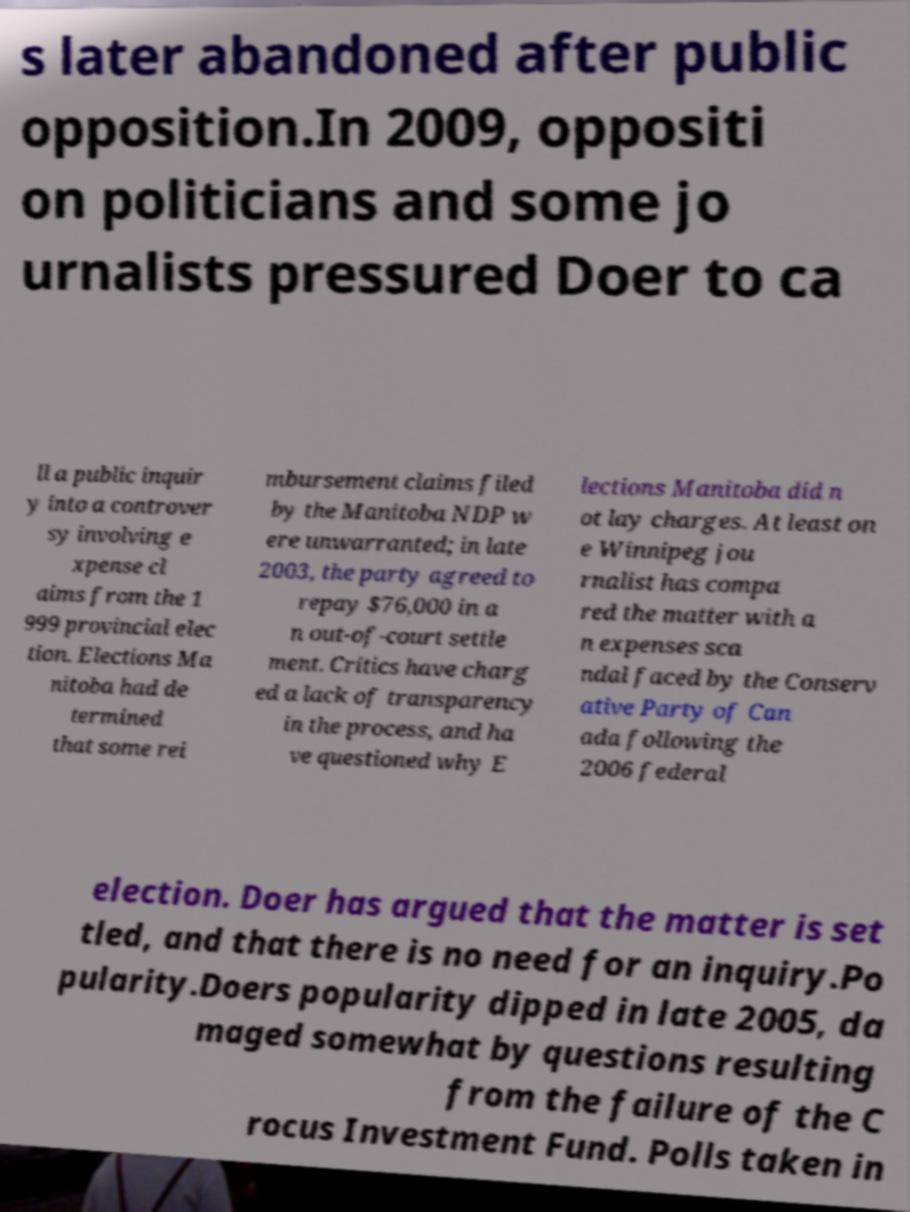Could you extract and type out the text from this image? s later abandoned after public opposition.In 2009, oppositi on politicians and some jo urnalists pressured Doer to ca ll a public inquir y into a controver sy involving e xpense cl aims from the 1 999 provincial elec tion. Elections Ma nitoba had de termined that some rei mbursement claims filed by the Manitoba NDP w ere unwarranted; in late 2003, the party agreed to repay $76,000 in a n out-of-court settle ment. Critics have charg ed a lack of transparency in the process, and ha ve questioned why E lections Manitoba did n ot lay charges. At least on e Winnipeg jou rnalist has compa red the matter with a n expenses sca ndal faced by the Conserv ative Party of Can ada following the 2006 federal election. Doer has argued that the matter is set tled, and that there is no need for an inquiry.Po pularity.Doers popularity dipped in late 2005, da maged somewhat by questions resulting from the failure of the C rocus Investment Fund. Polls taken in 